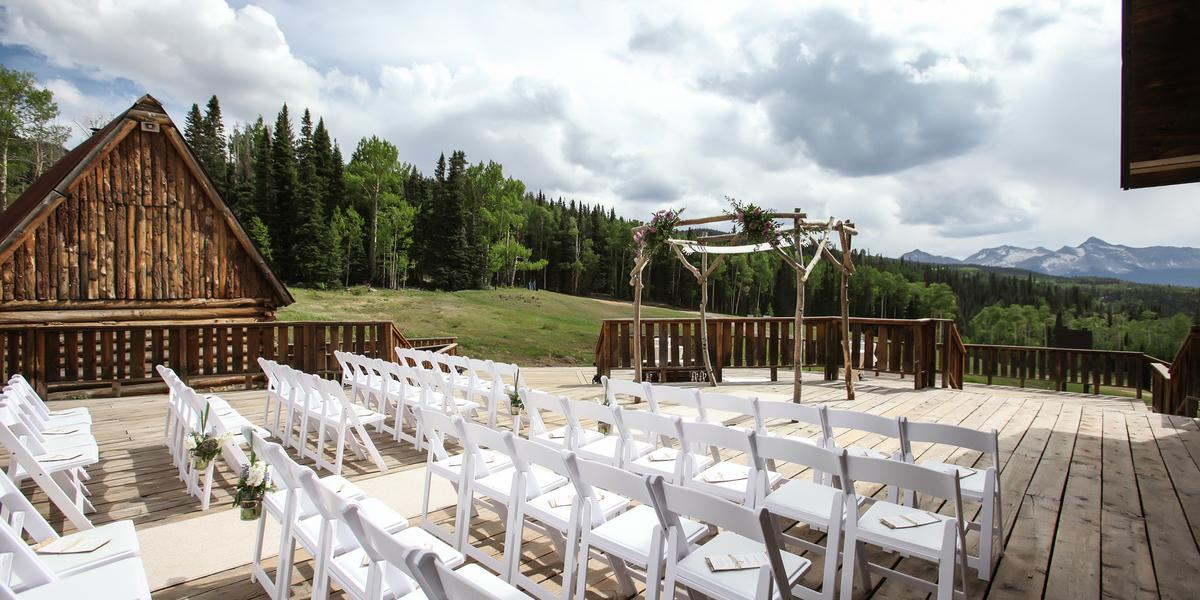How might the weather affect an event at this location, and what preparations could be necessary? Outdoor events at this venue could potentially be impacted by variable mountain weather, which could include sudden rain or changes in temperature. To mitigate these factors, it would be prudent to arrange for weather-resistant tents or canopies that can be quickly deployed. Additionally, providing blankets or heaters could ensure guest comfort in cooler temperatures. Advanced planning to provide clear, weather-related instructions to guests would also be essential to ensure a seamless event experience. 